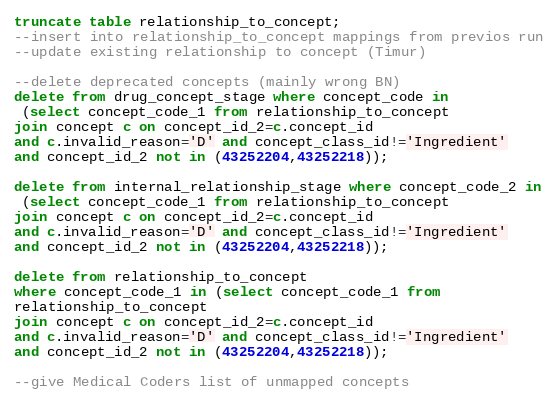Convert code to text. <code><loc_0><loc_0><loc_500><loc_500><_SQL_>truncate table relationship_to_concept;
--insert into relationship_to_concept mappings from previos run
--update existing relationship to concept (Timur)

--delete deprecated concepts (mainly wrong BN)
delete from drug_concept_stage where concept_code in
 (select concept_code_1 from relationship_to_concept 
join concept c on concept_id_2=c.concept_id 
and c.invalid_reason='D' and concept_class_id!='Ingredient'
and concept_id_2 not in (43252204,43252218));

delete from internal_relationship_stage where concept_code_2 in
 (select concept_code_1 from relationship_to_concept 
join concept c on concept_id_2=c.concept_id 
and c.invalid_reason='D' and concept_class_id!='Ingredient'
and concept_id_2 not in (43252204,43252218));

delete from relationship_to_concept 
where concept_code_1 in (select concept_code_1 from
relationship_to_concept
join concept c on concept_id_2=c.concept_id 
and c.invalid_reason='D' and concept_class_id!='Ingredient'
and concept_id_2 not in (43252204,43252218));

--give Medical Coders list of unmapped concepts</code> 